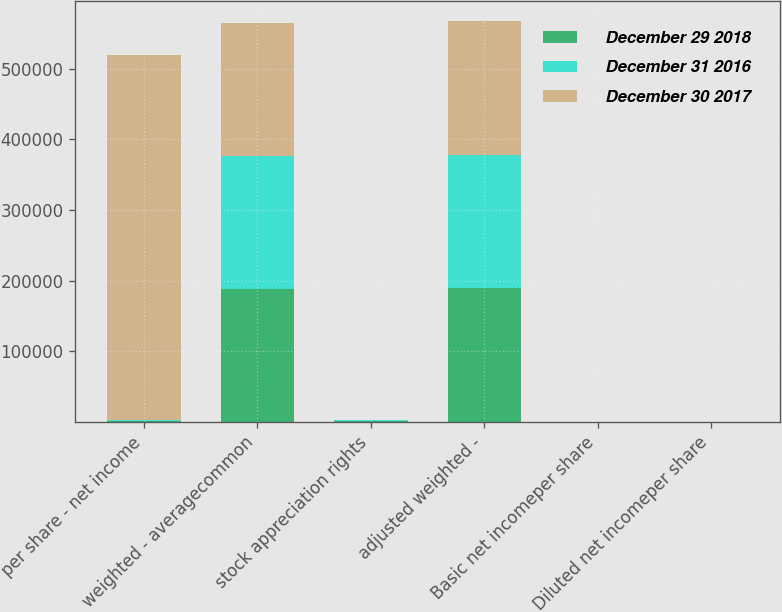<chart> <loc_0><loc_0><loc_500><loc_500><stacked_bar_chart><ecel><fcel>per share - net income<fcel>weighted - averagecommon<fcel>stock appreciation rights<fcel>adjusted weighted -<fcel>Basic net incomeper share<fcel>Diluted net incomeper share<nl><fcel>December 29 2018<fcel>1001.5<fcel>188635<fcel>1099<fcel>189734<fcel>3.68<fcel>3.66<nl><fcel>December 31 2016<fcel>1001.5<fcel>187828<fcel>904<fcel>188732<fcel>3.77<fcel>3.76<nl><fcel>December 30 2017<fcel>517724<fcel>188818<fcel>525<fcel>189343<fcel>2.74<fcel>2.73<nl></chart> 